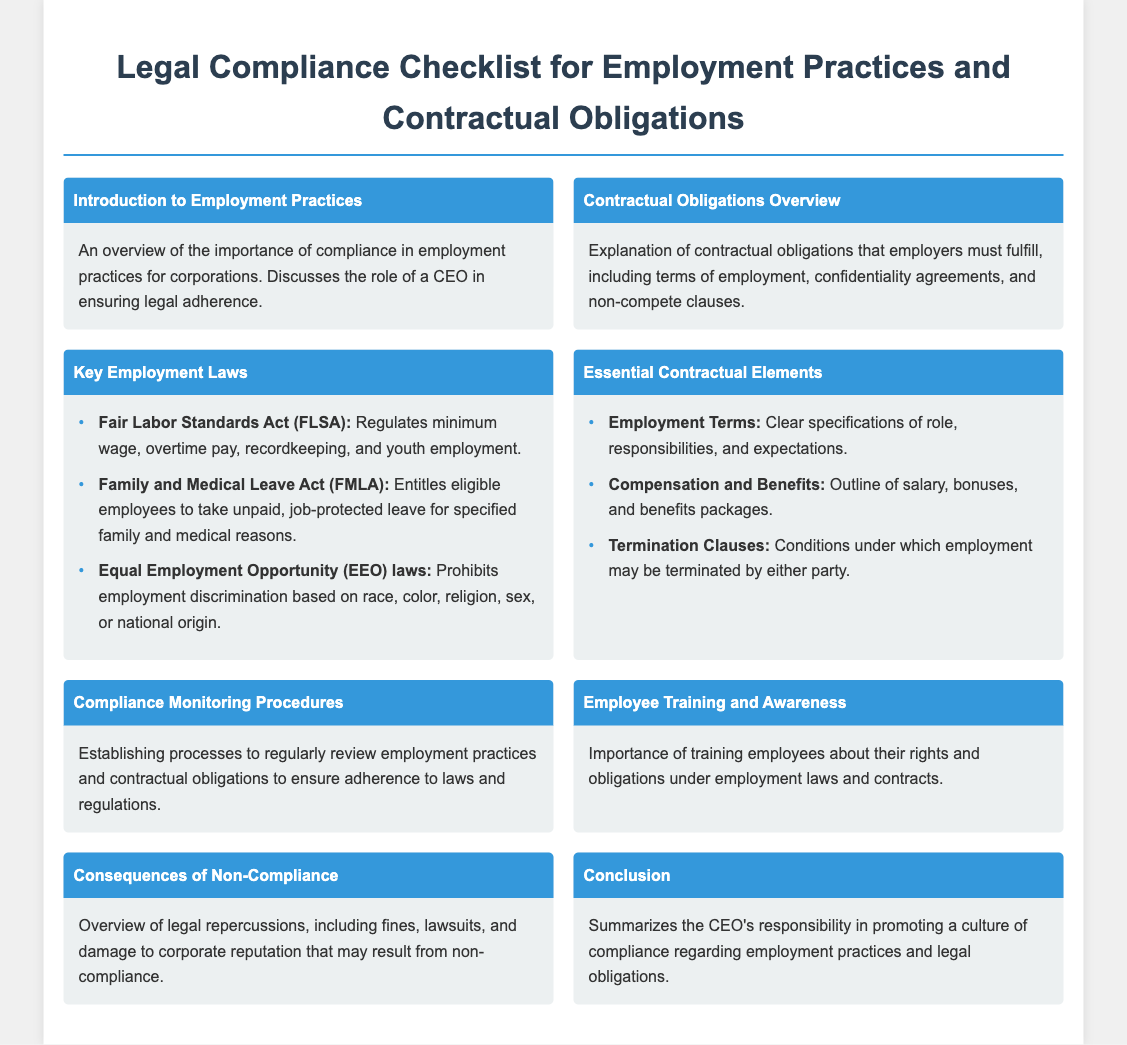What is the title of the document? The title is found at the top of the document, indicating the topic it covers.
Answer: Legal Compliance Checklist for Employment Practices and Contractual Obligations What act regulates minimum wage and overtime pay? This information is in the section about Key Employment Laws, specifically mentioning a specific act.
Answer: Fair Labor Standards Act (FLSA) How many key employment laws are listed? The number of key employment laws can be counted from the list provided in the document.
Answer: Three What is a consequence of non-compliance mentioned? The document summarizes the legal repercussions in a section about non-compliance, mentioning specific types of consequences.
Answer: Fines What should employment terms specify? This is outlined in the Essential Contractual Elements section and indicates what details need to be included.
Answer: Role, responsibilities, and expectations What is the importance of employee training? The relevance of training is discussed in a specific section that emphasizes the education of employees regarding their rights.
Answer: Rights and obligations What does the compliance monitoring procedure involve? This portion of the document addresses the methods put in place to ensure adherence to laws.
Answer: Regular review of practices What is the focus of the conclusion section? The conclusion summarizes the main responsibilities of the CEO in a particular aspect discussed in the document.
Answer: Promoting a culture of compliance 